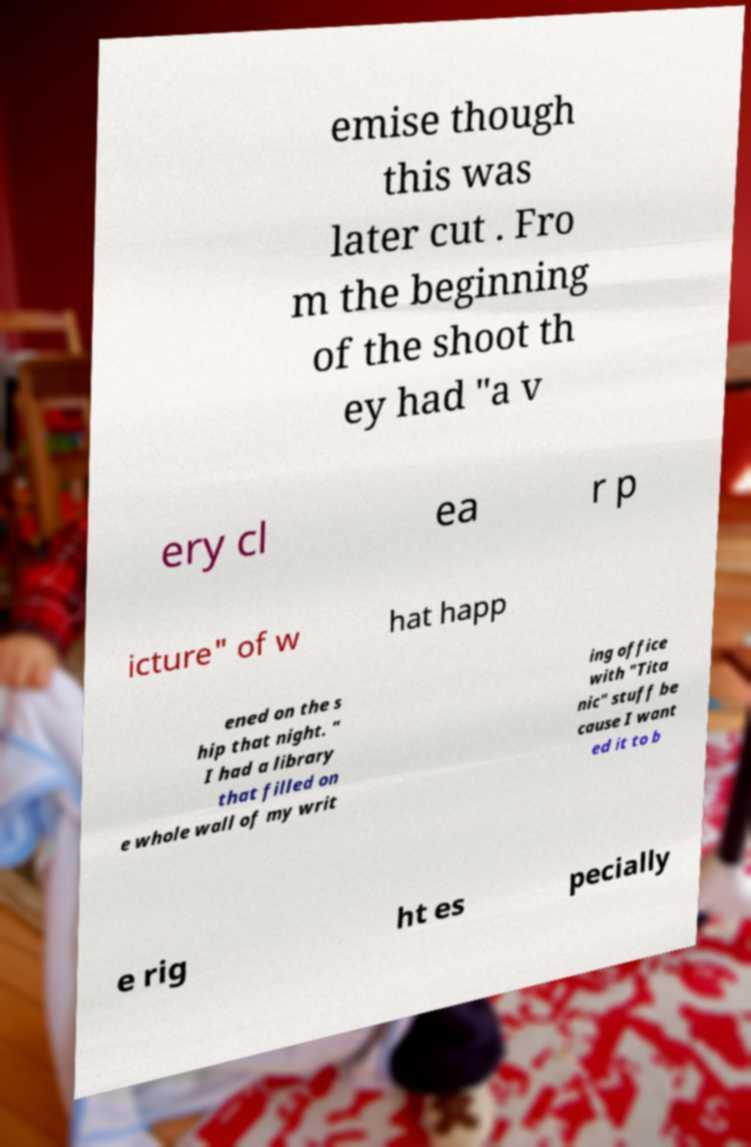Could you assist in decoding the text presented in this image and type it out clearly? emise though this was later cut . Fro m the beginning of the shoot th ey had "a v ery cl ea r p icture" of w hat happ ened on the s hip that night. " I had a library that filled on e whole wall of my writ ing office with "Tita nic" stuff be cause I want ed it to b e rig ht es pecially 